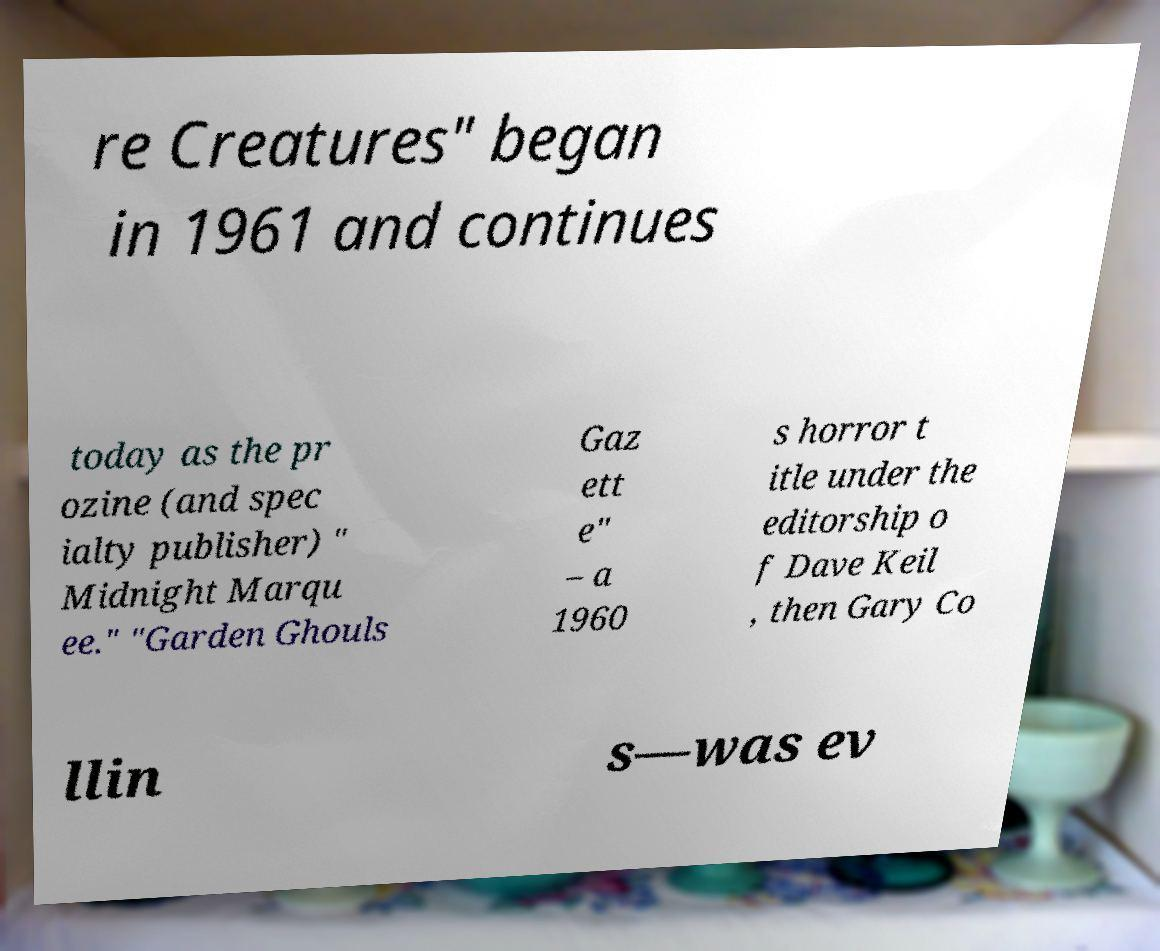Could you assist in decoding the text presented in this image and type it out clearly? re Creatures" began in 1961 and continues today as the pr ozine (and spec ialty publisher) " Midnight Marqu ee." "Garden Ghouls Gaz ett e" – a 1960 s horror t itle under the editorship o f Dave Keil , then Gary Co llin s—was ev 